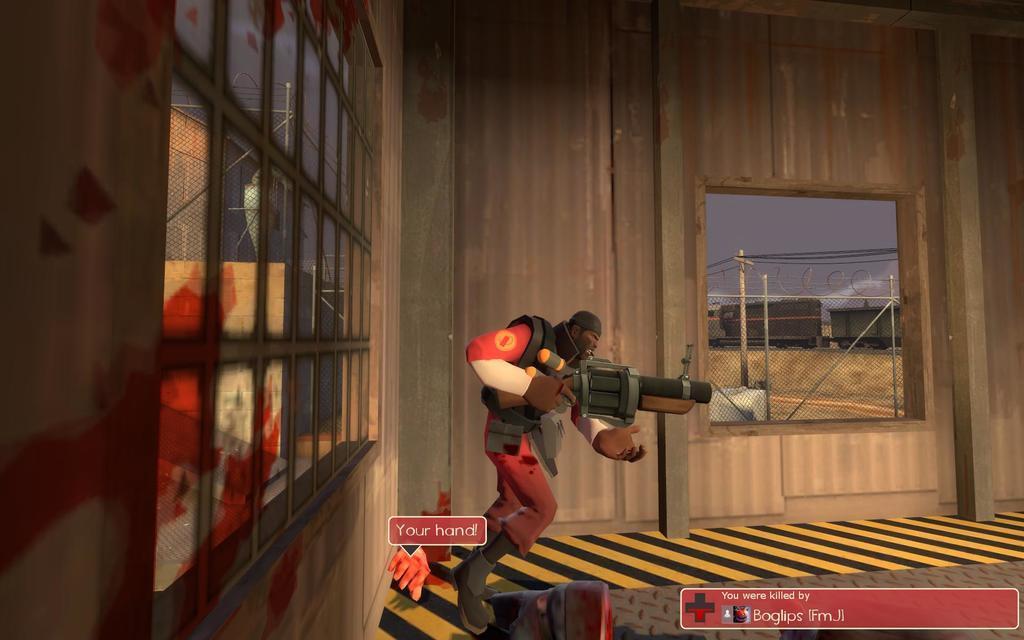Describe this image in one or two sentences. This image is an animated image. In the background there is a wooden wall with windows. Through the window we can see there is a train and there are two poles with a few wires. There is a net. There is the sky. At the bottom of the image there is a text. In the middle of the image a man is standing and he is holding a gun in his hands. 